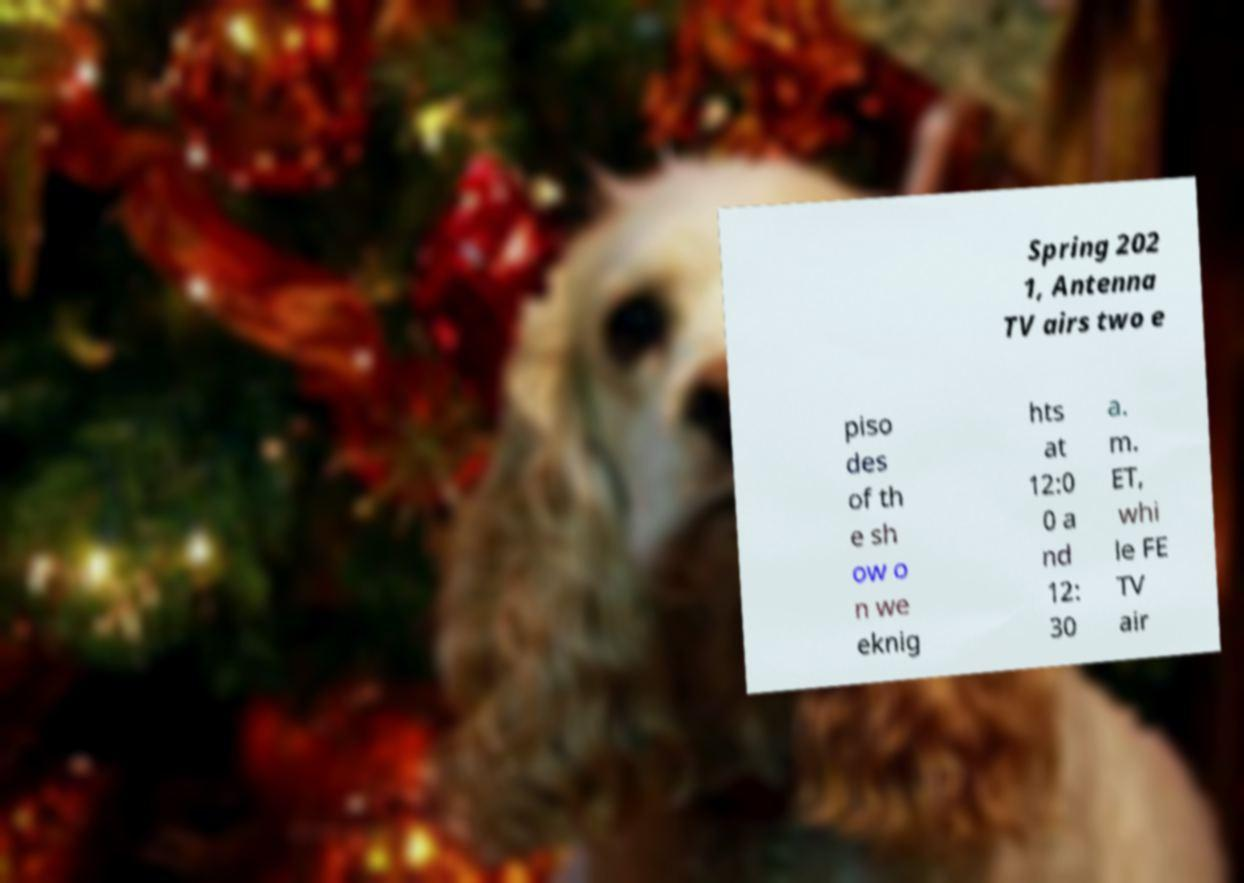Please read and relay the text visible in this image. What does it say? Spring 202 1, Antenna TV airs two e piso des of th e sh ow o n we eknig hts at 12:0 0 a nd 12: 30 a. m. ET, whi le FE TV air 